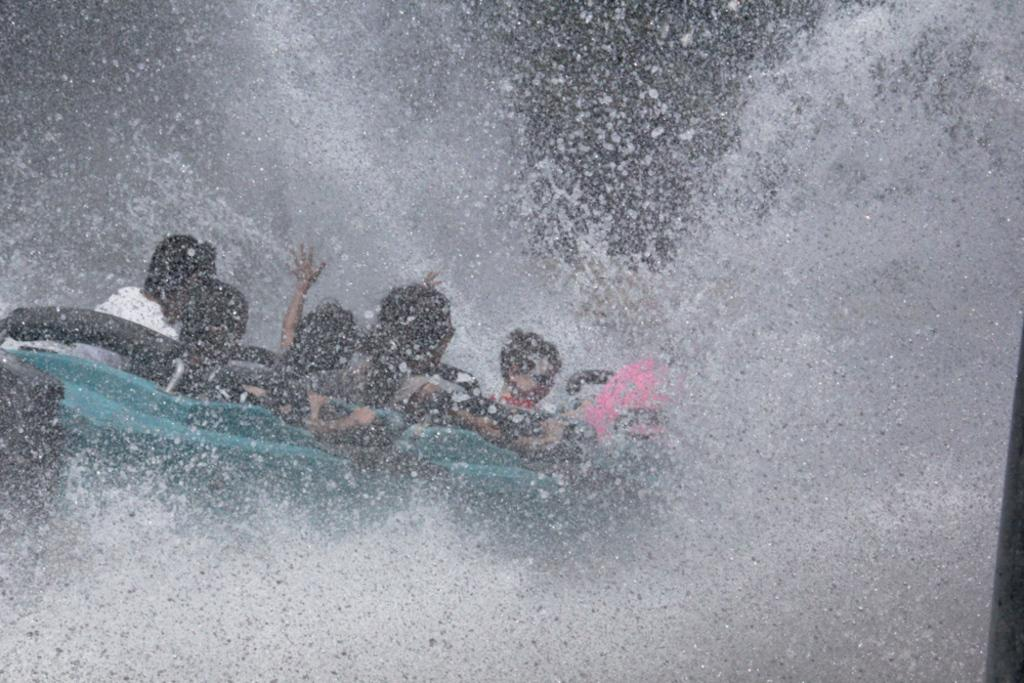What is happening in the image? There is a group of people in the image. Where are the people located? The people are seated in a boat. What can be seen in the background of the image? There is water visible in the image. What type of whip is being used by the people in the image? There is no whip present in the image. Where can the market be found in the image? There is no market present in the image. 